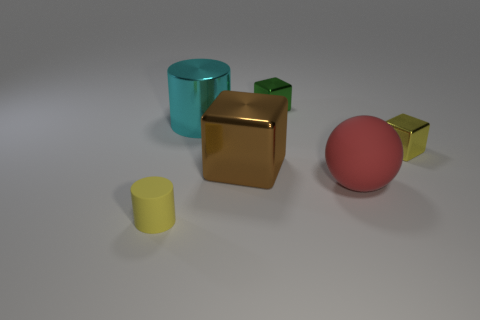There is a metal object to the right of the large rubber object; does it have the same shape as the small metal thing to the left of the red rubber sphere?
Ensure brevity in your answer.  Yes. There is a brown shiny thing that is the same size as the red object; what shape is it?
Offer a very short reply. Cube. Are the object right of the big matte ball and the yellow thing that is on the left side of the ball made of the same material?
Offer a very short reply. No. There is a metal block that is to the right of the green object; are there any red rubber balls that are on the left side of it?
Your answer should be compact. Yes. There is a big cube that is the same material as the large cyan object; what color is it?
Provide a succinct answer. Brown. Is the number of tiny green metallic things greater than the number of tiny brown cylinders?
Provide a short and direct response. Yes. What number of objects are tiny yellow things behind the tiny yellow cylinder or large cyan shiny balls?
Ensure brevity in your answer.  1. Is there a yellow shiny thing that has the same size as the yellow matte thing?
Your response must be concise. Yes. Is the number of blue rubber balls less than the number of cyan cylinders?
Provide a short and direct response. Yes. How many balls are big cyan metal objects or small yellow metallic things?
Provide a short and direct response. 0. 